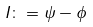<formula> <loc_0><loc_0><loc_500><loc_500>I \colon = \psi - \phi</formula> 